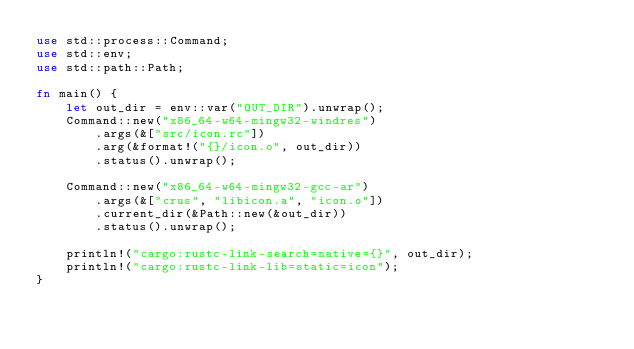<code> <loc_0><loc_0><loc_500><loc_500><_Rust_>use std::process::Command;
use std::env;
use std::path::Path;

fn main() {
    let out_dir = env::var("OUT_DIR").unwrap();
    Command::new("x86_64-w64-mingw32-windres")
        .args(&["src/icon.rc"])
        .arg(&format!("{}/icon.o", out_dir))
        .status().unwrap();
    
    Command::new("x86_64-w64-mingw32-gcc-ar")
        .args(&["crus", "libicon.a", "icon.o"])
        .current_dir(&Path::new(&out_dir))
        .status().unwrap();

    println!("cargo:rustc-link-search=native={}", out_dir);
    println!("cargo:rustc-link-lib=static=icon");
}
</code> 